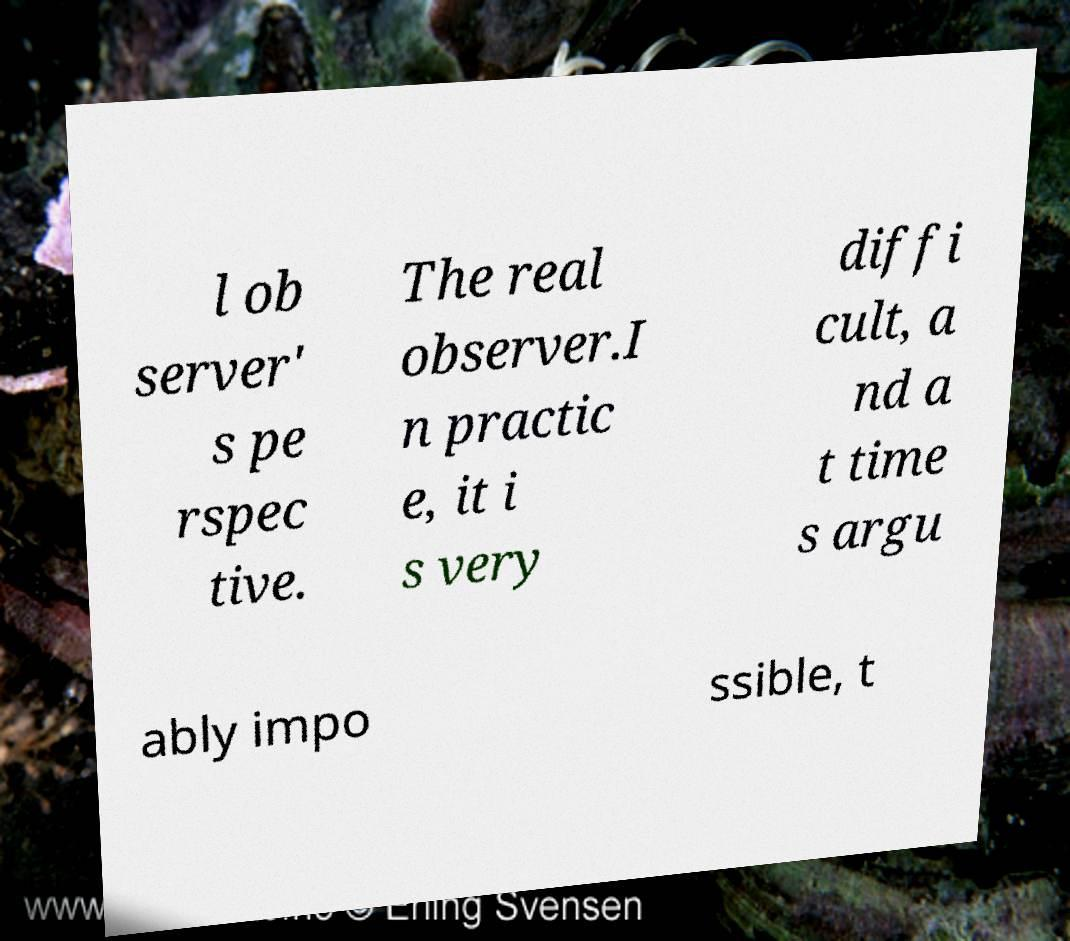Please identify and transcribe the text found in this image. l ob server' s pe rspec tive. The real observer.I n practic e, it i s very diffi cult, a nd a t time s argu ably impo ssible, t 